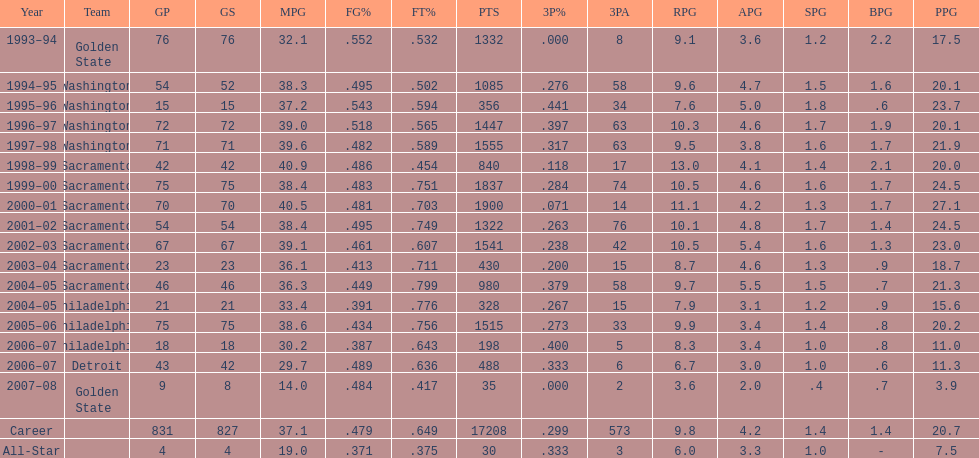How many seasons did webber average over 20 points per game (ppg)? 11. 